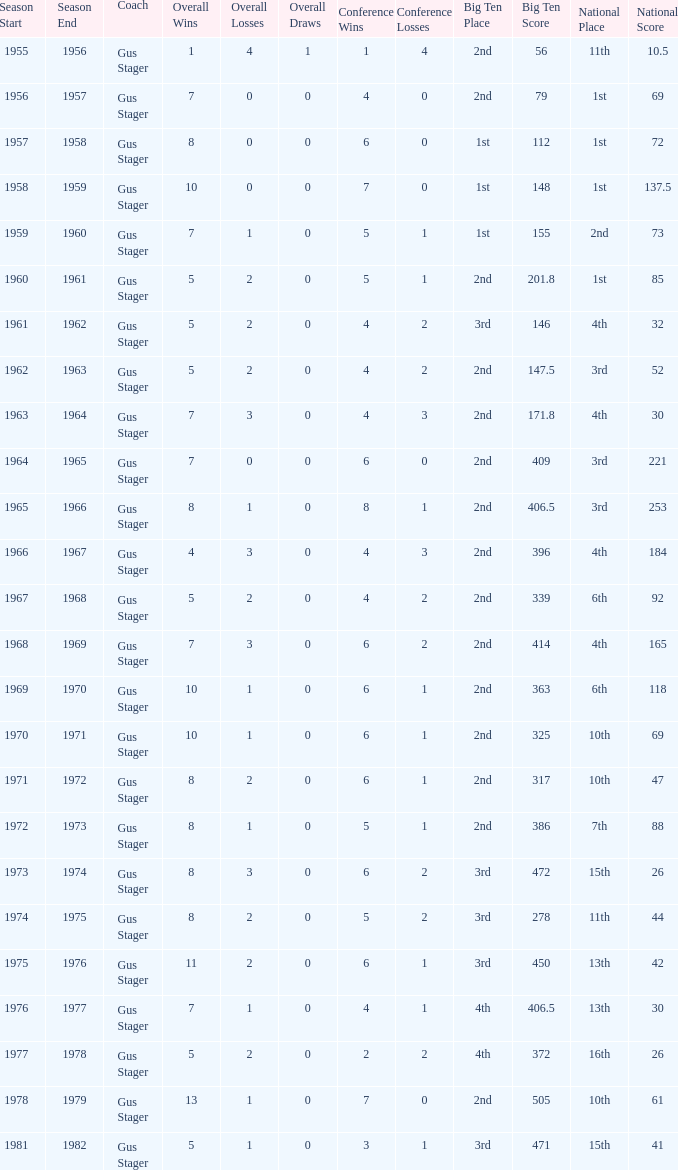What is the Season with a Big Ten that is 2nd (386)? 1972-73. 